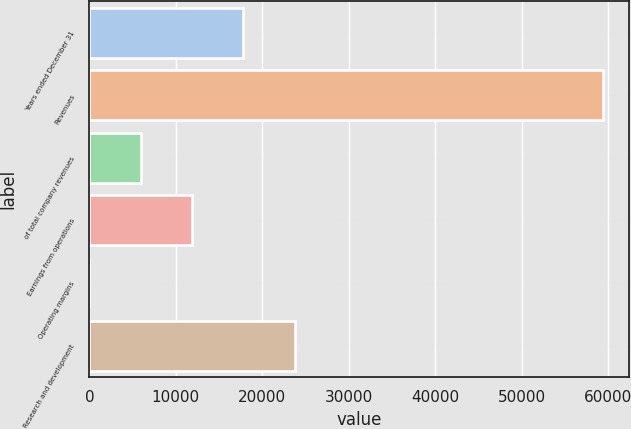Convert chart to OTSL. <chart><loc_0><loc_0><loc_500><loc_500><bar_chart><fcel>Years ended December 31<fcel>Revenues<fcel>of total company revenues<fcel>Earnings from operations<fcel>Operating margins<fcel>Research and development<nl><fcel>17815.7<fcel>59378<fcel>5940.77<fcel>11878.2<fcel>3.3<fcel>23753.2<nl></chart> 